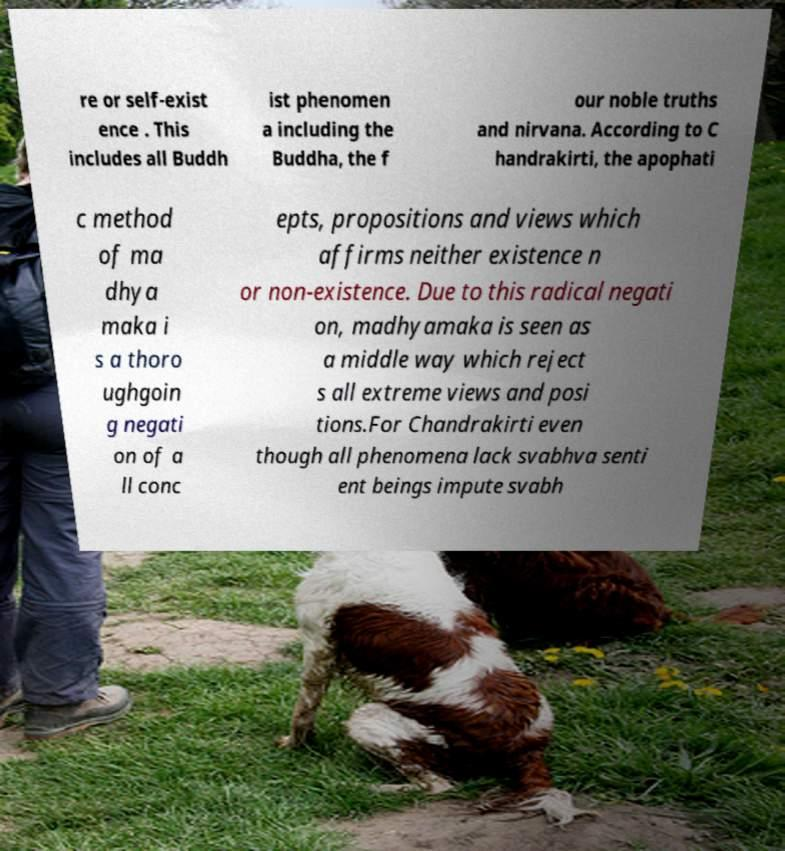For documentation purposes, I need the text within this image transcribed. Could you provide that? re or self-exist ence . This includes all Buddh ist phenomen a including the Buddha, the f our noble truths and nirvana. According to C handrakirti, the apophati c method of ma dhya maka i s a thoro ughgoin g negati on of a ll conc epts, propositions and views which affirms neither existence n or non-existence. Due to this radical negati on, madhyamaka is seen as a middle way which reject s all extreme views and posi tions.For Chandrakirti even though all phenomena lack svabhva senti ent beings impute svabh 